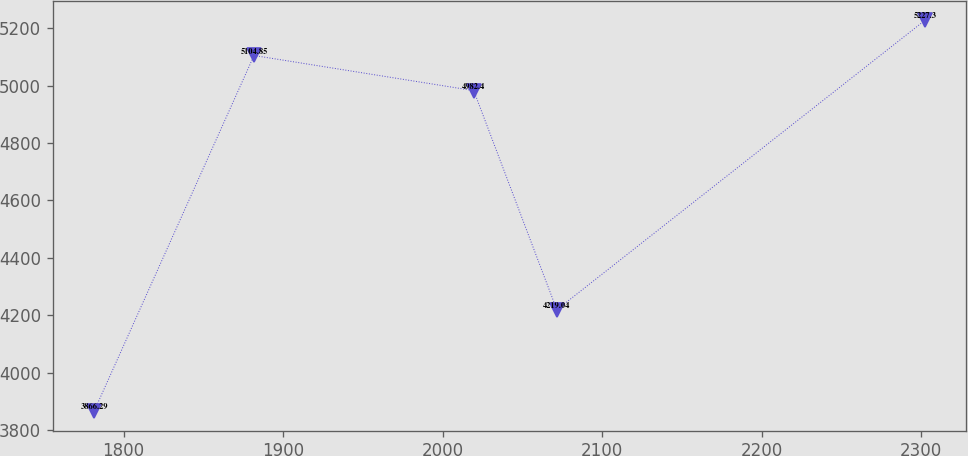<chart> <loc_0><loc_0><loc_500><loc_500><line_chart><ecel><fcel>Unnamed: 1<nl><fcel>1781.57<fcel>3866.29<nl><fcel>1881.74<fcel>5104.85<nl><fcel>2019.46<fcel>4982.4<nl><fcel>2071.52<fcel>4219.04<nl><fcel>2302.21<fcel>5227.3<nl></chart> 